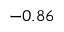Convert formula to latex. <formula><loc_0><loc_0><loc_500><loc_500>- 0 . 8 6</formula> 